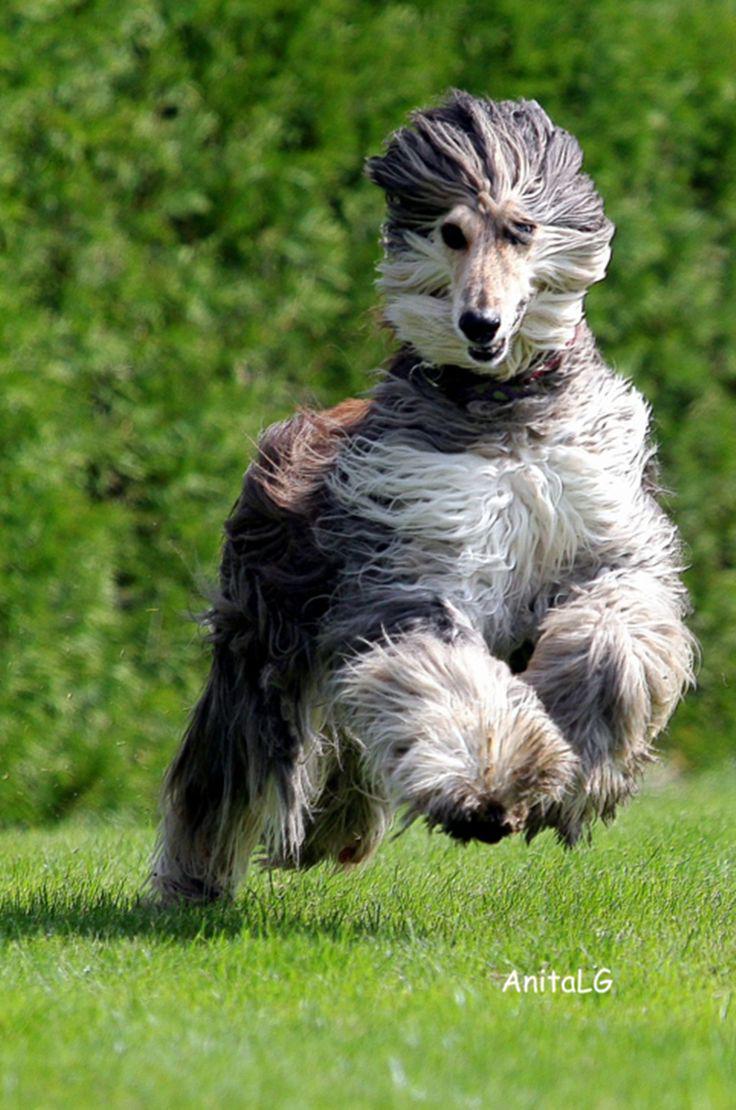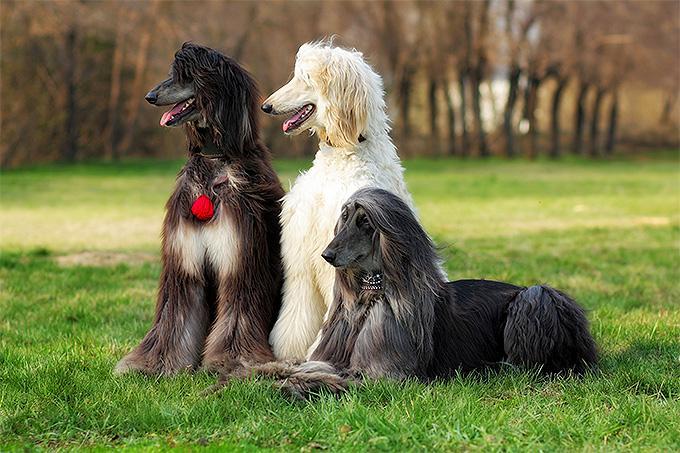The first image is the image on the left, the second image is the image on the right. Given the left and right images, does the statement "One image shows a hound bounding across the grass." hold true? Answer yes or no. Yes. The first image is the image on the left, the second image is the image on the right. Considering the images on both sides, is "There is a dog running in one of the images." valid? Answer yes or no. Yes. 